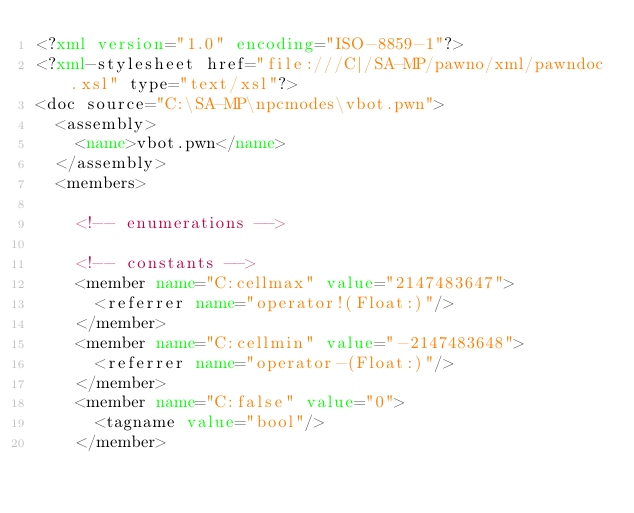<code> <loc_0><loc_0><loc_500><loc_500><_XML_><?xml version="1.0" encoding="ISO-8859-1"?>
<?xml-stylesheet href="file:///C|/SA-MP/pawno/xml/pawndoc.xsl" type="text/xsl"?>
<doc source="C:\SA-MP\npcmodes\vbot.pwn">
	<assembly>
		<name>vbot.pwn</name>
	</assembly>
	<members>

		<!-- enumerations -->

		<!-- constants -->
		<member name="C:cellmax" value="2147483647">
			<referrer name="operator!(Float:)"/>
		</member>
		<member name="C:cellmin" value="-2147483648">
			<referrer name="operator-(Float:)"/>
		</member>
		<member name="C:false" value="0">
			<tagname value="bool"/>
		</member></code> 